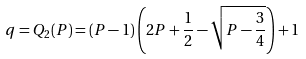<formula> <loc_0><loc_0><loc_500><loc_500>q = Q _ { 2 } ( P ) = \left ( P - 1 \right ) \left ( 2 P + \frac { 1 } { 2 } - \sqrt { P - \frac { 3 } { 4 } } \right ) + 1</formula> 